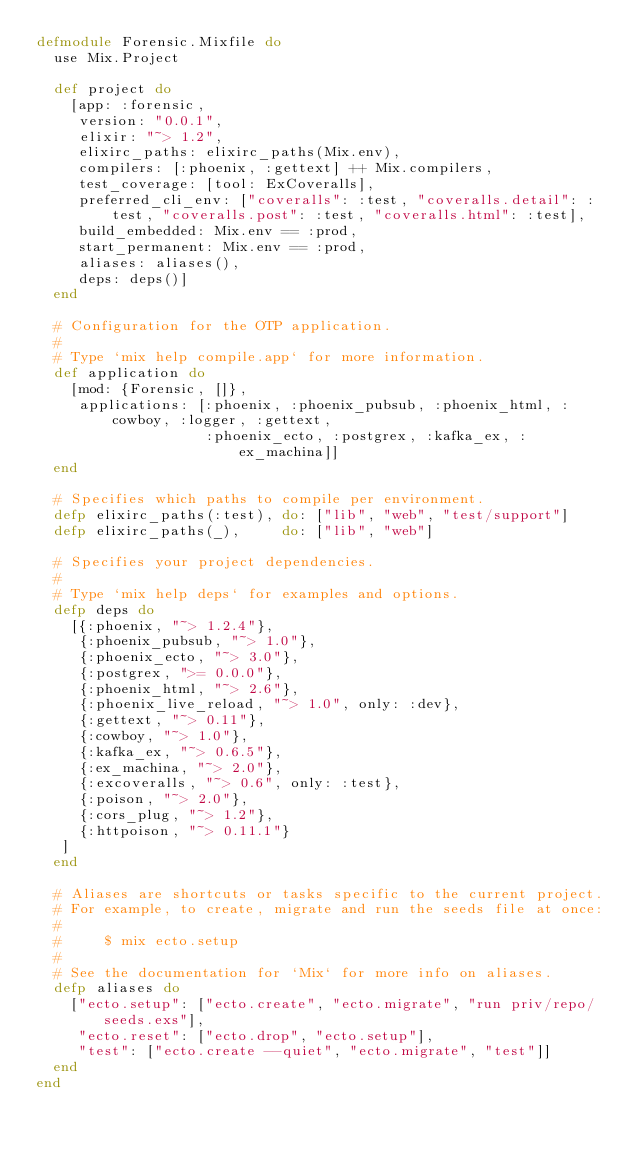<code> <loc_0><loc_0><loc_500><loc_500><_Elixir_>defmodule Forensic.Mixfile do
  use Mix.Project

  def project do
    [app: :forensic,
     version: "0.0.1",
     elixir: "~> 1.2",
     elixirc_paths: elixirc_paths(Mix.env),
     compilers: [:phoenix, :gettext] ++ Mix.compilers,
     test_coverage: [tool: ExCoveralls],
     preferred_cli_env: ["coveralls": :test, "coveralls.detail": :test, "coveralls.post": :test, "coveralls.html": :test],
     build_embedded: Mix.env == :prod,
     start_permanent: Mix.env == :prod,
     aliases: aliases(),
     deps: deps()]
  end

  # Configuration for the OTP application.
  #
  # Type `mix help compile.app` for more information.
  def application do
    [mod: {Forensic, []},
     applications: [:phoenix, :phoenix_pubsub, :phoenix_html, :cowboy, :logger, :gettext,
                    :phoenix_ecto, :postgrex, :kafka_ex, :ex_machina]]
  end

  # Specifies which paths to compile per environment.
  defp elixirc_paths(:test), do: ["lib", "web", "test/support"]
  defp elixirc_paths(_),     do: ["lib", "web"]

  # Specifies your project dependencies.
  #
  # Type `mix help deps` for examples and options.
  defp deps do
    [{:phoenix, "~> 1.2.4"},
     {:phoenix_pubsub, "~> 1.0"},
     {:phoenix_ecto, "~> 3.0"},
     {:postgrex, ">= 0.0.0"},
     {:phoenix_html, "~> 2.6"},
     {:phoenix_live_reload, "~> 1.0", only: :dev},
     {:gettext, "~> 0.11"},
     {:cowboy, "~> 1.0"},
     {:kafka_ex, "~> 0.6.5"},
     {:ex_machina, "~> 2.0"},
     {:excoveralls, "~> 0.6", only: :test},
     {:poison, "~> 2.0"},
     {:cors_plug, "~> 1.2"},
     {:httpoison, "~> 0.11.1"}
   ]
  end

  # Aliases are shortcuts or tasks specific to the current project.
  # For example, to create, migrate and run the seeds file at once:
  #
  #     $ mix ecto.setup
  #
  # See the documentation for `Mix` for more info on aliases.
  defp aliases do
    ["ecto.setup": ["ecto.create", "ecto.migrate", "run priv/repo/seeds.exs"],
     "ecto.reset": ["ecto.drop", "ecto.setup"],
     "test": ["ecto.create --quiet", "ecto.migrate", "test"]]
  end
end
</code> 